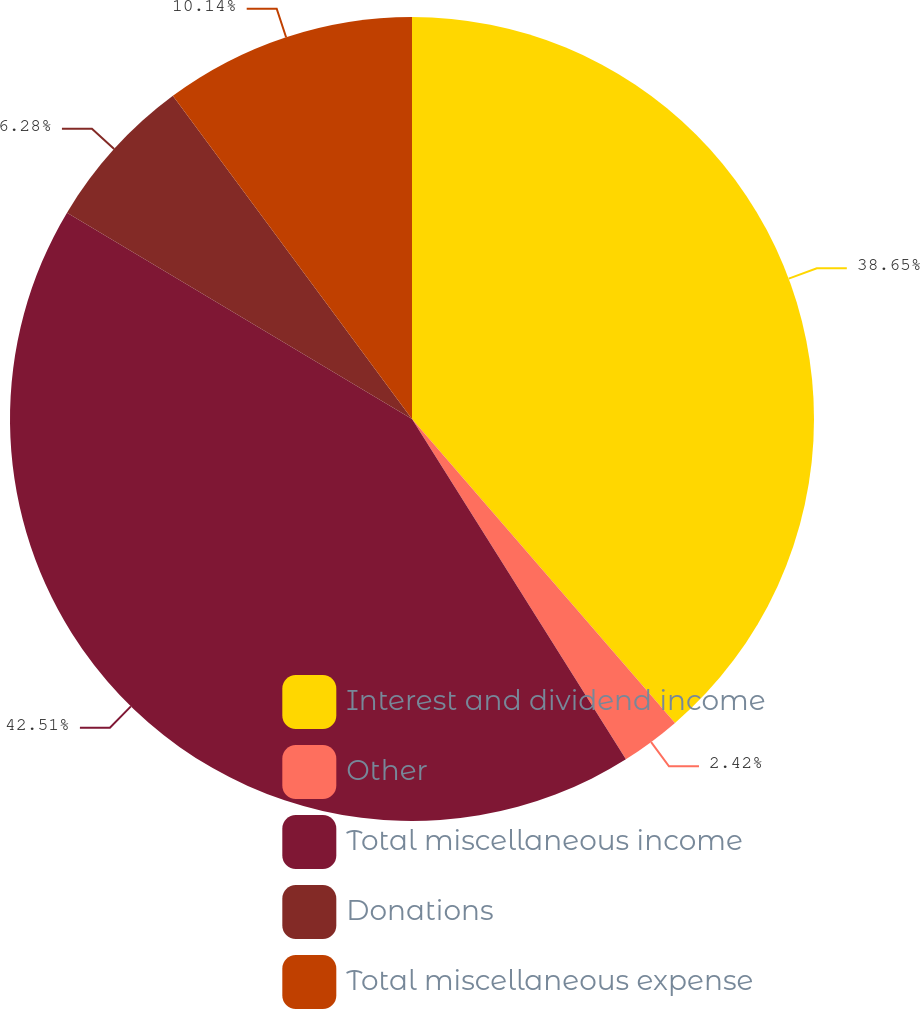Convert chart. <chart><loc_0><loc_0><loc_500><loc_500><pie_chart><fcel>Interest and dividend income<fcel>Other<fcel>Total miscellaneous income<fcel>Donations<fcel>Total miscellaneous expense<nl><fcel>38.65%<fcel>2.42%<fcel>42.51%<fcel>6.28%<fcel>10.14%<nl></chart> 